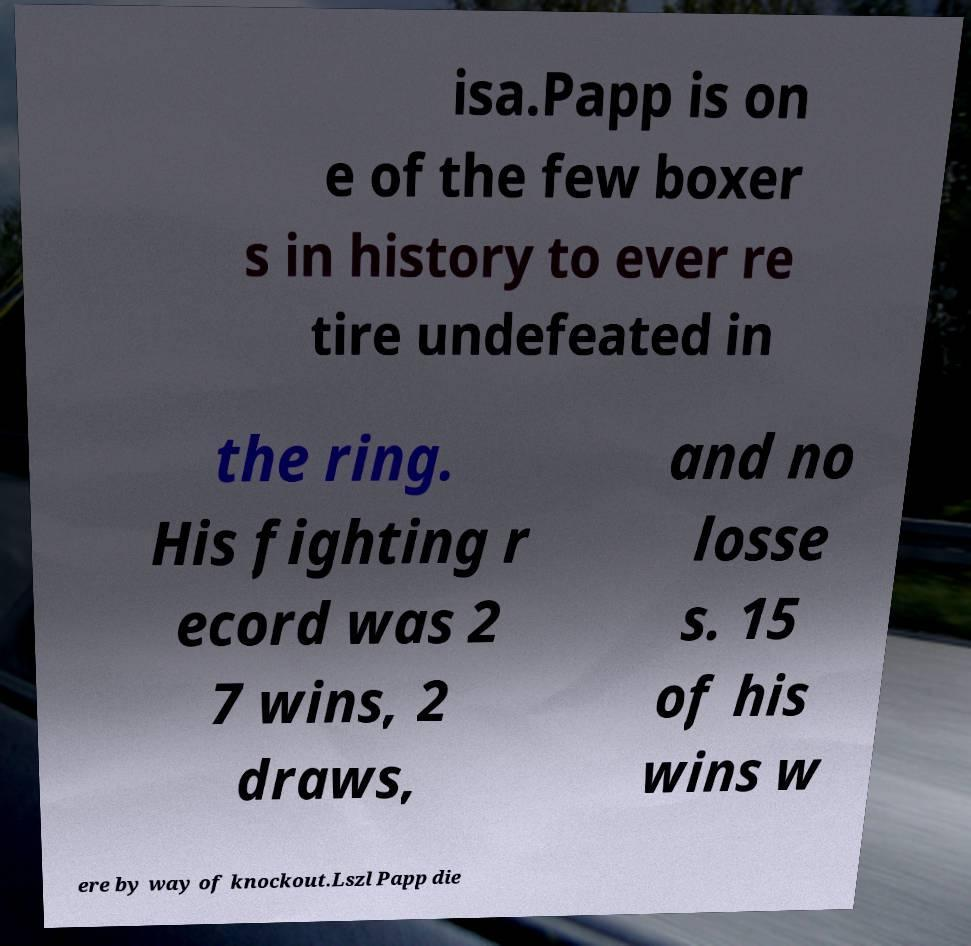Please identify and transcribe the text found in this image. isa.Papp is on e of the few boxer s in history to ever re tire undefeated in the ring. His fighting r ecord was 2 7 wins, 2 draws, and no losse s. 15 of his wins w ere by way of knockout.Lszl Papp die 